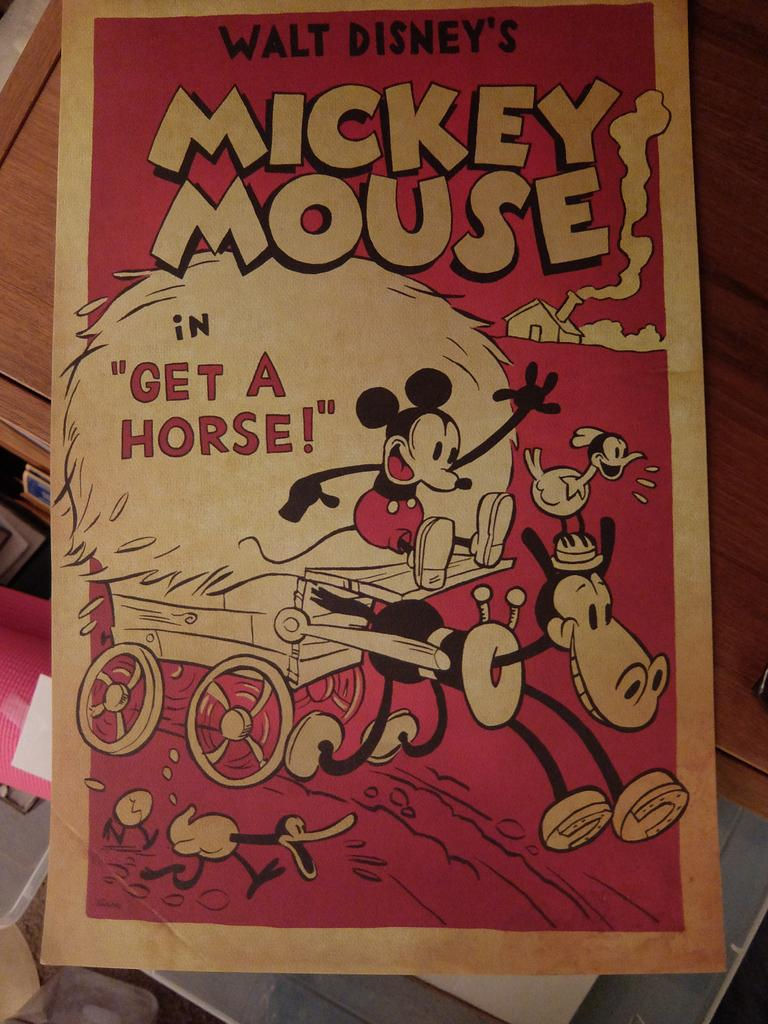<image>
Offer a succinct explanation of the picture presented. A poster for the Mickey Mouse cartoon "Get a Horse" features Mickey riding on a hay wagon. 